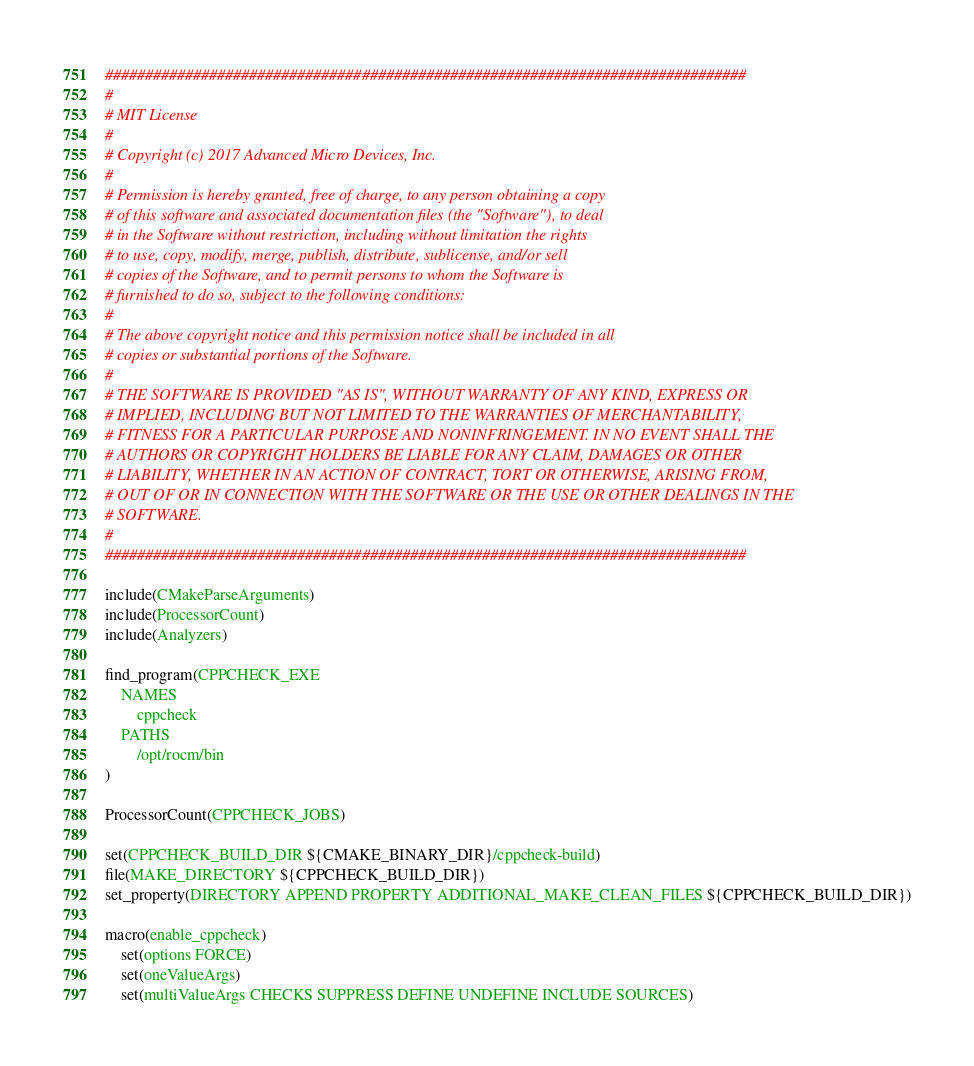<code> <loc_0><loc_0><loc_500><loc_500><_CMake_>################################################################################
# 
# MIT License
# 
# Copyright (c) 2017 Advanced Micro Devices, Inc.
# 
# Permission is hereby granted, free of charge, to any person obtaining a copy
# of this software and associated documentation files (the "Software"), to deal
# in the Software without restriction, including without limitation the rights
# to use, copy, modify, merge, publish, distribute, sublicense, and/or sell
# copies of the Software, and to permit persons to whom the Software is
# furnished to do so, subject to the following conditions:
# 
# The above copyright notice and this permission notice shall be included in all
# copies or substantial portions of the Software.
# 
# THE SOFTWARE IS PROVIDED "AS IS", WITHOUT WARRANTY OF ANY KIND, EXPRESS OR
# IMPLIED, INCLUDING BUT NOT LIMITED TO THE WARRANTIES OF MERCHANTABILITY,
# FITNESS FOR A PARTICULAR PURPOSE AND NONINFRINGEMENT. IN NO EVENT SHALL THE
# AUTHORS OR COPYRIGHT HOLDERS BE LIABLE FOR ANY CLAIM, DAMAGES OR OTHER
# LIABILITY, WHETHER IN AN ACTION OF CONTRACT, TORT OR OTHERWISE, ARISING FROM,
# OUT OF OR IN CONNECTION WITH THE SOFTWARE OR THE USE OR OTHER DEALINGS IN THE
# SOFTWARE.
# 
################################################################################

include(CMakeParseArguments)
include(ProcessorCount)
include(Analyzers)

find_program(CPPCHECK_EXE 
    NAMES 
        cppcheck
    PATHS
        /opt/rocm/bin
)

ProcessorCount(CPPCHECK_JOBS)

set(CPPCHECK_BUILD_DIR ${CMAKE_BINARY_DIR}/cppcheck-build)
file(MAKE_DIRECTORY ${CPPCHECK_BUILD_DIR})
set_property(DIRECTORY APPEND PROPERTY ADDITIONAL_MAKE_CLEAN_FILES ${CPPCHECK_BUILD_DIR})

macro(enable_cppcheck)
    set(options FORCE)
    set(oneValueArgs)
    set(multiValueArgs CHECKS SUPPRESS DEFINE UNDEFINE INCLUDE SOURCES)
</code> 